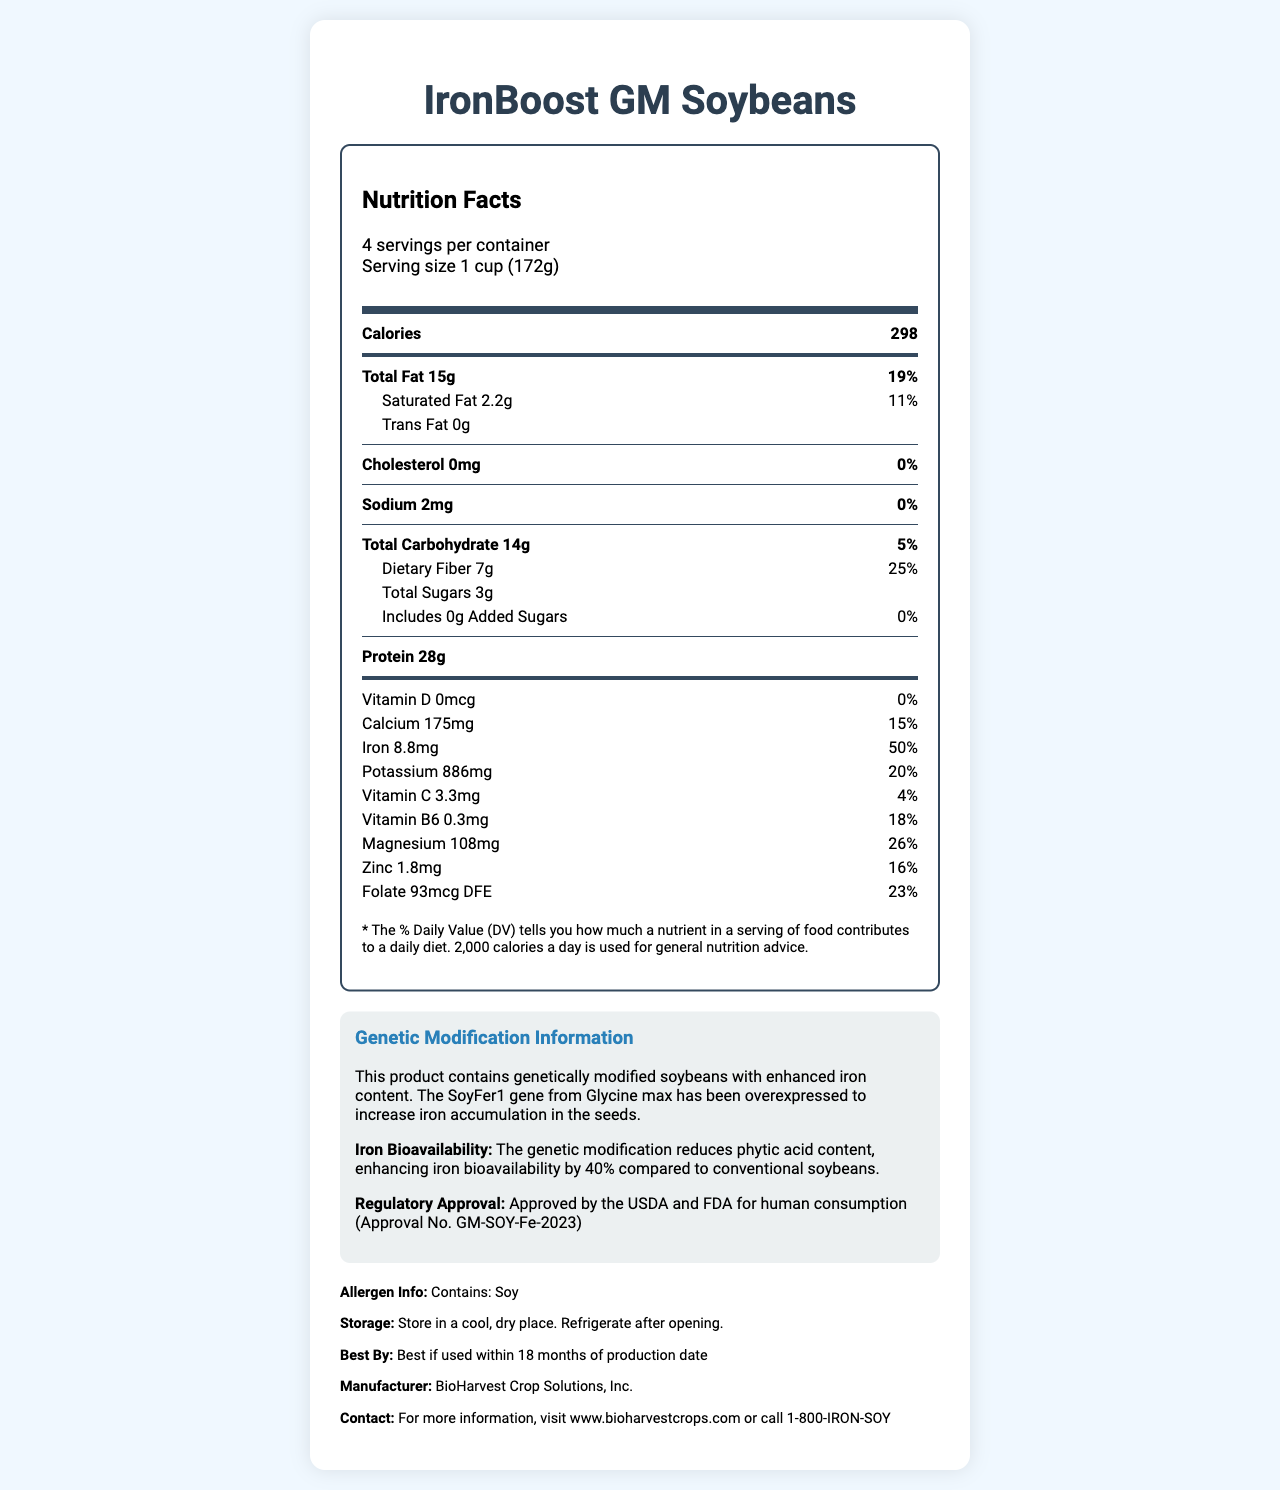what is the product name? The product name is specified at the top and in the title of the document.
Answer: IronBoost GM Soybeans what is the iron content per serving? In the nutrition facts section, it is shown that iron content per serving is 8.8mg.
Answer: 8.8mg which nutrient has the highest daily value percentage? A. Iron B. Protein C. Magnesium D. Fiber Iron has the highest daily value percentage at 50%.
Answer: A. Iron how many servings are per container? The document states that there are 4 servings per container.
Answer: 4 what is the amount of protein per serving? The nutrition facts section lists the protein content as 28g per serving.
Answer: 28g what is the expiration date of the product? The additional info section specifies the expiration date as best if used within 18 months of production date.
Answer: Best if used within 18 months of production date what is the dietary fiber content per serving? The dietary fiber content per serving is mentioned as 7g in the nutrition facts part.
Answer: 7g what vitamin has 0% of daily value? A. Vitamin D B. Calcium C. Vitamin C D. Vitamin B6 Vitamin D has 0% of the daily value.
Answer: A. Vitamin D True or False: The product contains genetically modified soybeans with enhanced iron content. The document clearly states that the soybeans are genetically modified with enhanced iron content.
Answer: True how is the product packaged for storage? The storage instructions in the additional info section recommend storing the product in a cool, dry place and refrigerating it after opening.
Answer: Store in a cool, dry place. Refrigerate after opening. describe the purpose and main features of this document The document outlines the nutritional facts, genetic modification information, regulatory status, storage instructions, and contact information for IronBoost GM Soybeans. It emphasizes the enhanced iron content and improved bioavailability due to genetic engineering.
Answer: This document provides nutritional information, the genetic modification details, storage instructions, regulatory approval, and manufacturer information for IronBoost GM Soybeans. It highlights the enhanced iron content achieved through genetic modification and specifies the allergen information and expiration date. how many calories come from fat per serving? The document does not provide specific information on the number of calories that come from fat per serving.
Answer: Not enough information 